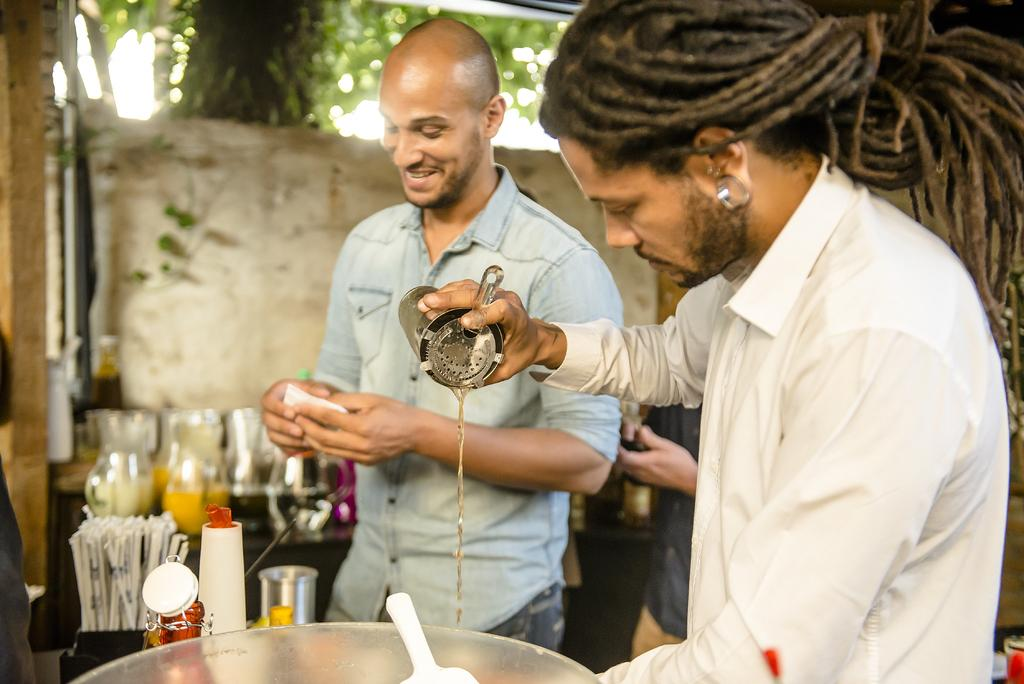Who or what can be seen in the image? There are people in the image. What objects are present on the tables? There are jugs and bottles on the tables. Can you describe any other items visible in the image? There are other things on the tables, but their specific nature is not mentioned in the facts. What can be seen in the background of the image? There is a tree in the background of the image. What type of flower is growing near the tree in the background? There is no flower mentioned or visible in the image. 